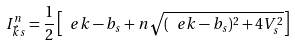Convert formula to latex. <formula><loc_0><loc_0><loc_500><loc_500>I _ { \vec { k } s } ^ { n } = \frac { 1 } { 2 } \left [ \ e k - b _ { s } + n \sqrt { ( \ e k - b _ { s } ) ^ { 2 } + 4 V _ { s } ^ { 2 } } \right ]</formula> 